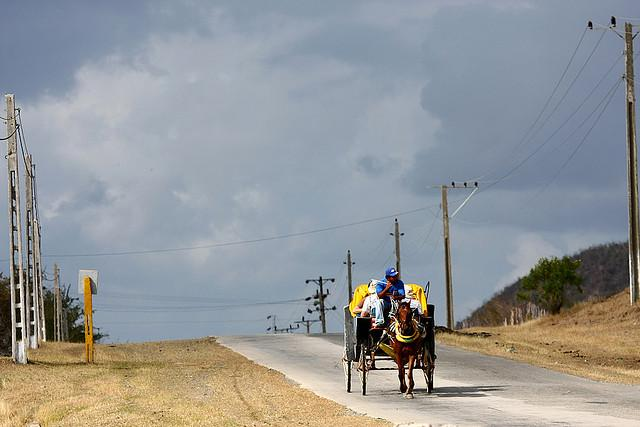What is the tallest item here?

Choices:
A) horse
B) building
C) bush
D) telephone pole telephone pole 